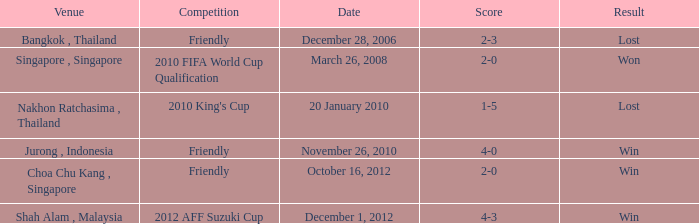Give me the full table as a dictionary. {'header': ['Venue', 'Competition', 'Date', 'Score', 'Result'], 'rows': [['Bangkok , Thailand', 'Friendly', 'December 28, 2006', '2-3', 'Lost'], ['Singapore , Singapore', '2010 FIFA World Cup Qualification', 'March 26, 2008', '2-0', 'Won'], ['Nakhon Ratchasima , Thailand', "2010 King's Cup", '20 January 2010', '1-5', 'Lost'], ['Jurong , Indonesia', 'Friendly', 'November 26, 2010', '4-0', 'Win'], ['Choa Chu Kang , Singapore', 'Friendly', 'October 16, 2012', '2-0', 'Win'], ['Shah Alam , Malaysia', '2012 AFF Suzuki Cup', 'December 1, 2012', '4-3', 'Win']]} Name the venue for friendly competition october 16, 2012 Choa Chu Kang , Singapore. 